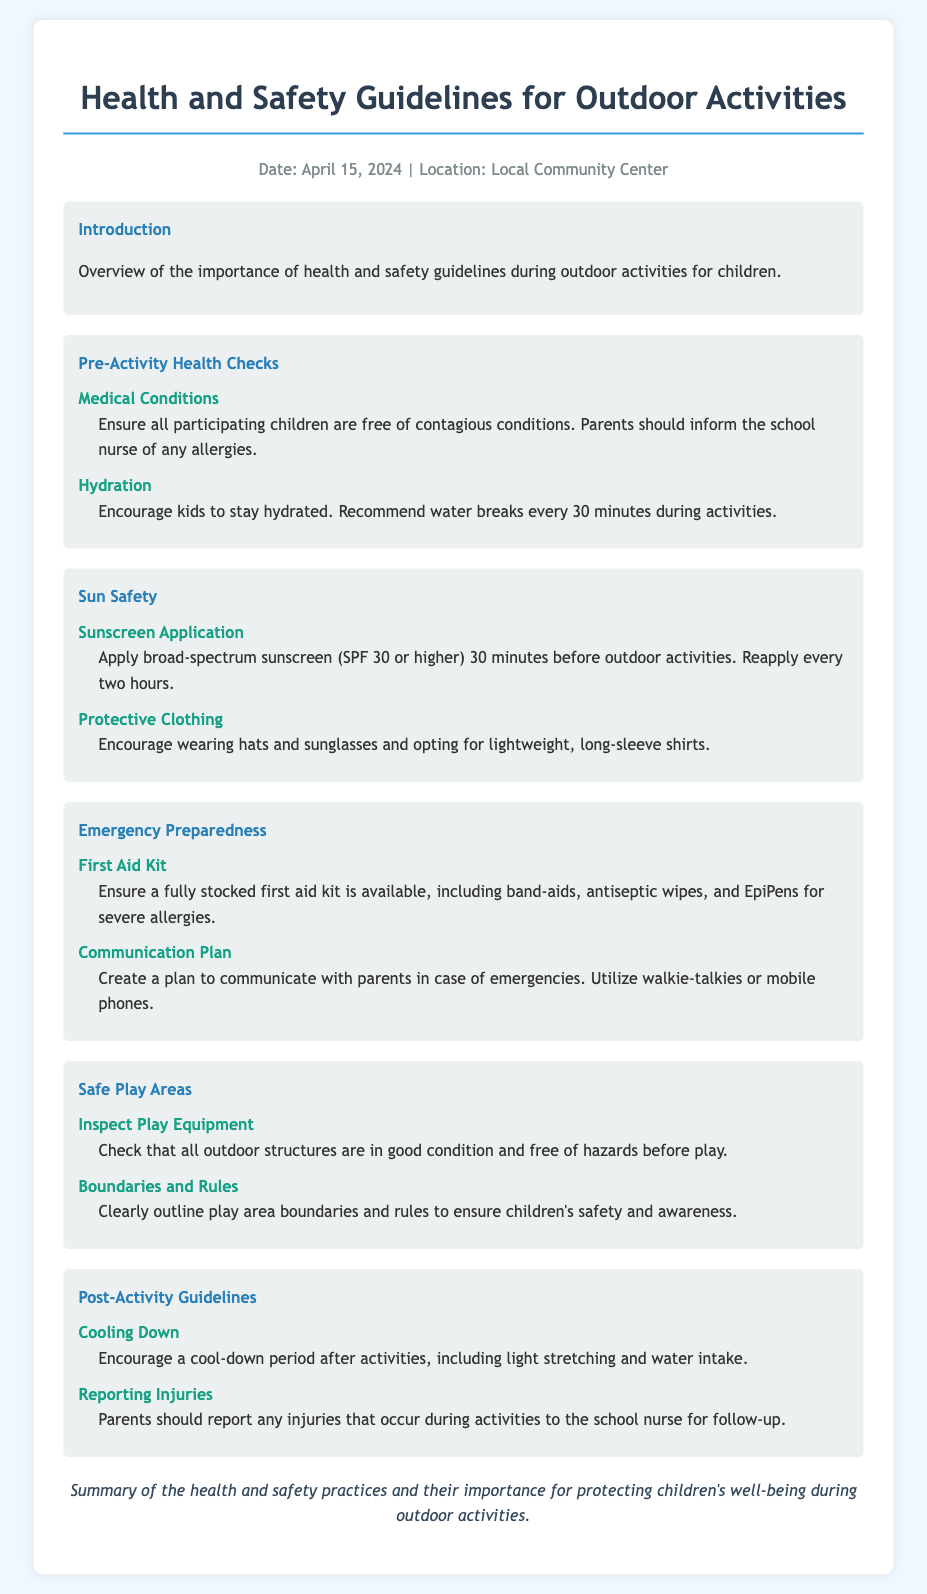what is the date of the document? The date of the document is specified at the top of the rendered document under the meta section.
Answer: April 15, 2024 what should parents inform the school nurse about? The document states that parents should inform the school nurse of any allergies concerning the children's health before activities.
Answer: allergies how often should water breaks be taken during activities? The guideline mentions that kids should take water breaks every 30 minutes during outdoor activities.
Answer: every 30 minutes what type of sunscreen should be applied? The document specifies the use of broad-spectrum sunscreen with a minimum SPF of 30 for protection against the sun.
Answer: broad-spectrum sunscreen (SPF 30 or higher) what should be included in the first aid kit? The first aid kit should include items like band-aids, antiseptic wipes, and EpiPens for severe allergies.
Answer: band-aids, antiseptic wipes, EpiPens why is a communication plan important? The document emphasizes the necessity of creating a communication plan to effectively inform parents in case of emergencies during outdoor activities.
Answer: emergencies what should be done after activities to promote safety? After activities, it is important to encourage a cool-down period and light stretching, according to the post-activity guidelines.
Answer: cool-down period who should report injuries that occur during activities? The document explicitly states that parents should report any injuries that happen during activities to the school nurse.
Answer: parents how should playground equipment be evaluated before use? The guideline indicates that all outdoor structures should be checked for good condition and free of hazards prior to children's play.
Answer: checked for good condition and free of hazards 